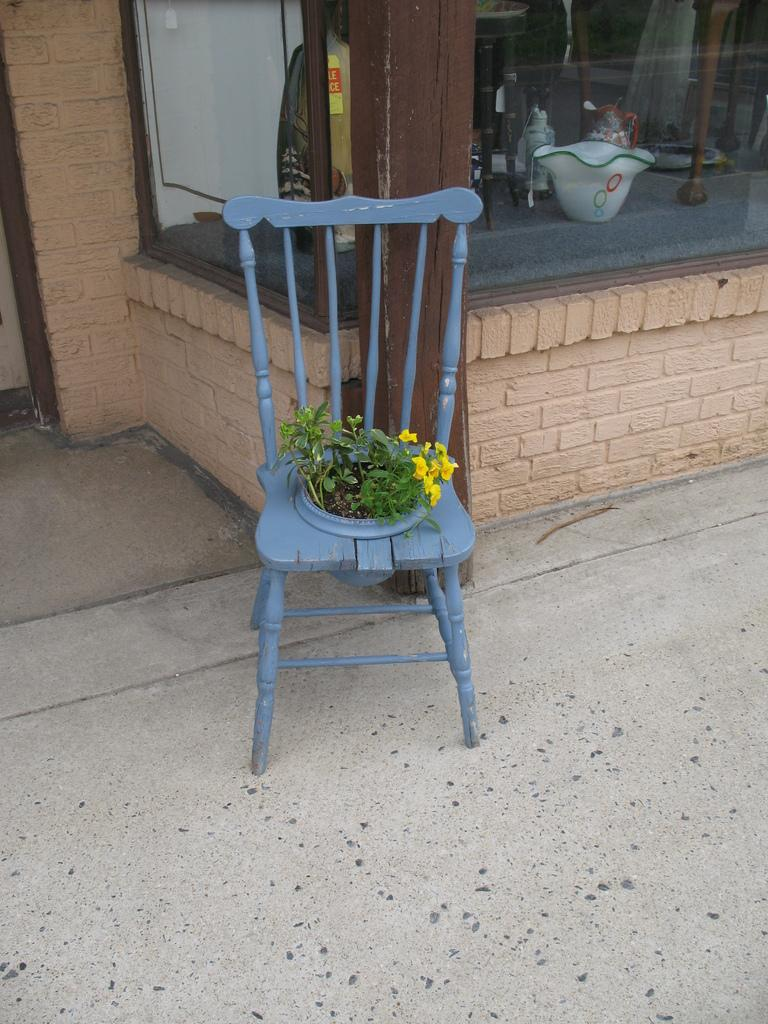What type of furniture is present in the image? There is a chair in the image. What is growing on the chair? Plants are growing on the chair. Is there any rain visible in the image? There is no rain visible in the image. How many steps are required to reach the chair in the image? The number of steps required to reach the chair cannot be determined from the image. 